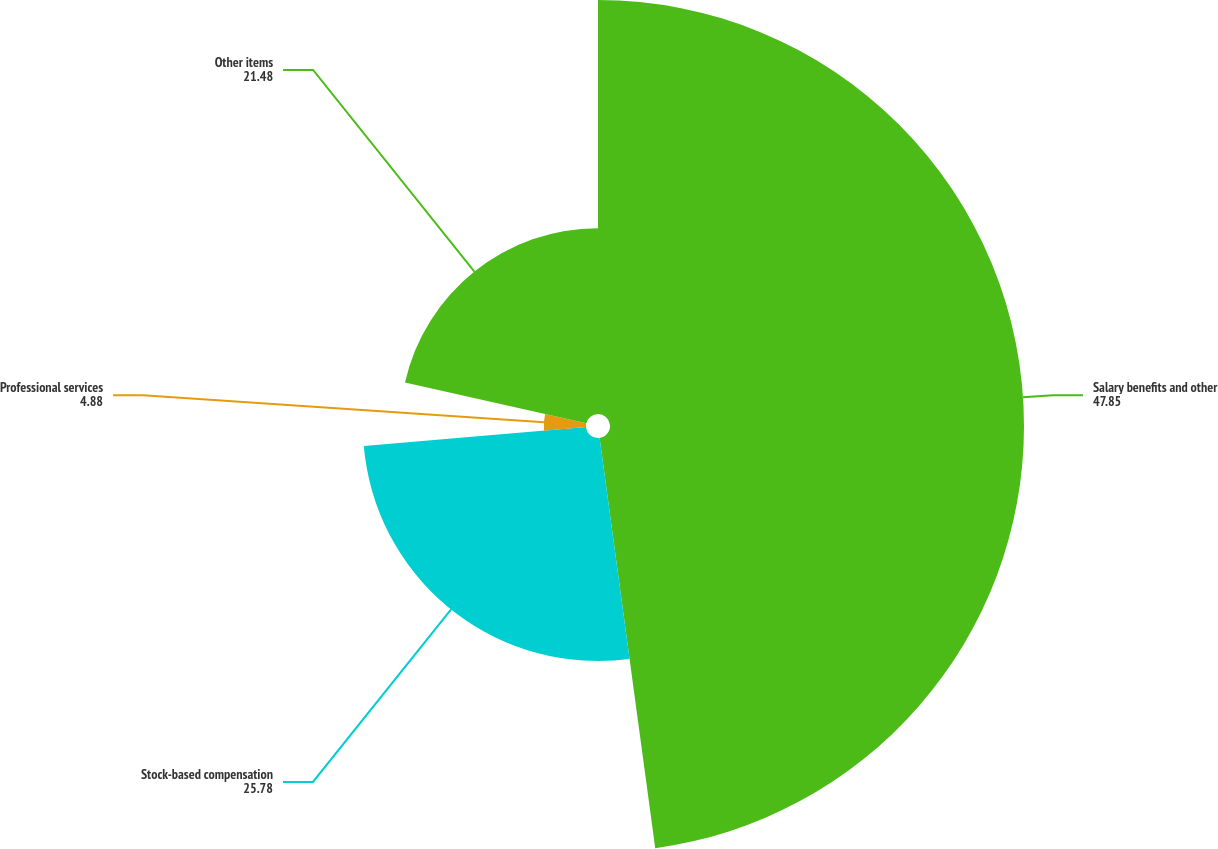Convert chart to OTSL. <chart><loc_0><loc_0><loc_500><loc_500><pie_chart><fcel>Salary benefits and other<fcel>Stock-based compensation<fcel>Professional services<fcel>Other items<nl><fcel>47.85%<fcel>25.78%<fcel>4.88%<fcel>21.48%<nl></chart> 